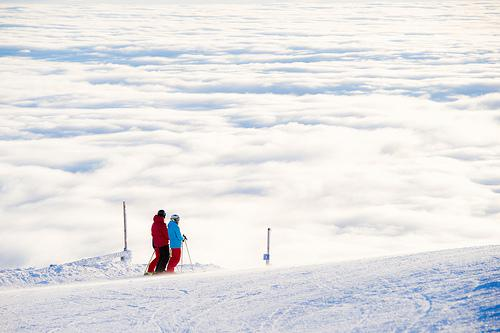Question: what are people doing?
Choices:
A. Snow skiing.
B. Water skiing.
C. Snowboarding.
D. Sledding.
Answer with the letter. Answer: A Question: why are people on mountain?
Choices:
A. To snow ski.
B. To snowboard.
C. To sled.
D. To camp.
Answer with the letter. Answer: A Question: when was picture taken?
Choices:
A. At midnight.
B. At dusk.
C. During daylight.
D. At sunset.
Answer with the letter. Answer: C Question: who is in the picture?
Choices:
A. Three people.
B. To people.
C. Four people.
D. No one.
Answer with the letter. Answer: B Question: what is in background?
Choices:
A. More snow.
B. More trees.
C. More grass.
D. More clouds.
Answer with the letter. Answer: A Question: how many people are in picture?
Choices:
A. One.
B. Three.
C. Four.
D. Two.
Answer with the letter. Answer: D 